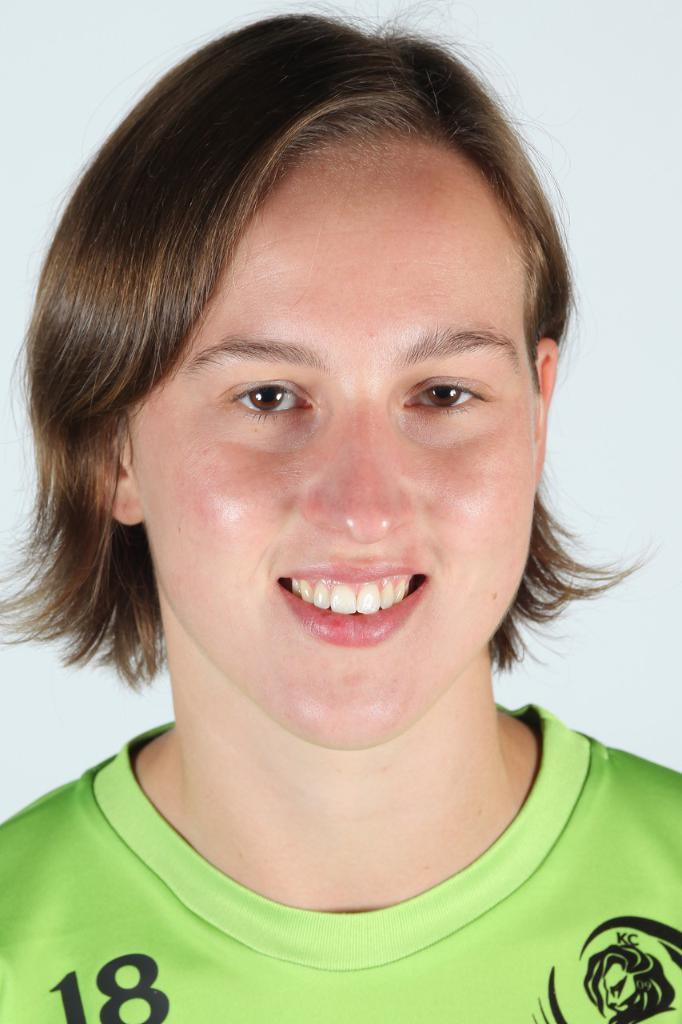Who is present in the image? There is a woman in the image. What can be seen in the background of the image? There is a wall visible in the image. What effect does the lake have on the woman in the image? There is no lake present in the image, so it cannot have any effect on the woman. 